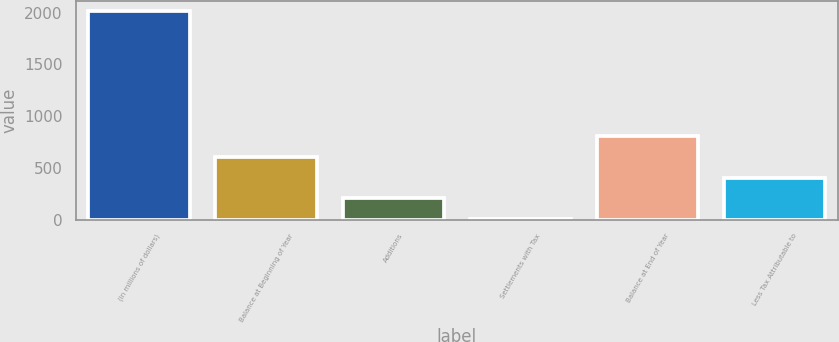Convert chart. <chart><loc_0><loc_0><loc_500><loc_500><bar_chart><fcel>(in millions of dollars)<fcel>Balance at Beginning of Year<fcel>Additions<fcel>Settlements with Tax<fcel>Balance at End of Year<fcel>Less Tax Attributable to<nl><fcel>2013<fcel>607.26<fcel>205.62<fcel>4.8<fcel>808.08<fcel>406.44<nl></chart> 